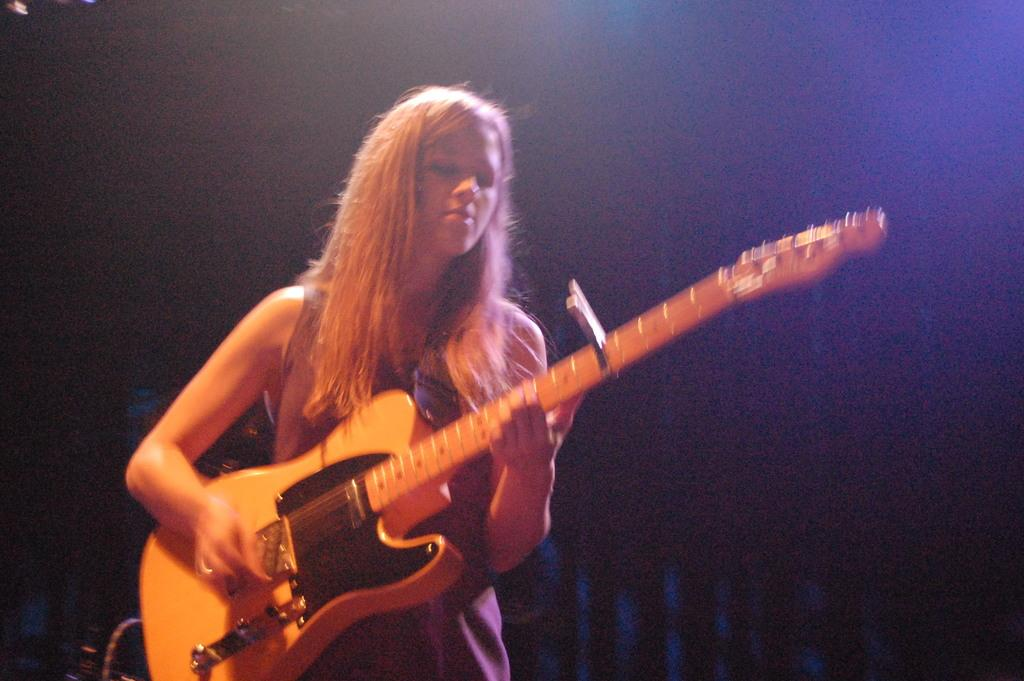Who is the main subject in the image? There is a woman in the image. What is the woman doing in the image? The woman is standing and playing the guitar with her right hand. How is the woman holding the guitar? The woman is holding the guitar with her left hand. What can be seen in the background of the image? There is a curtain in the background of the image. What type of club is the woman using to play the guitar in the image? The woman is not using a club to play the guitar; she is using her right hand to strum the strings. How many trucks are visible in the image? There are no trucks present in the image. 